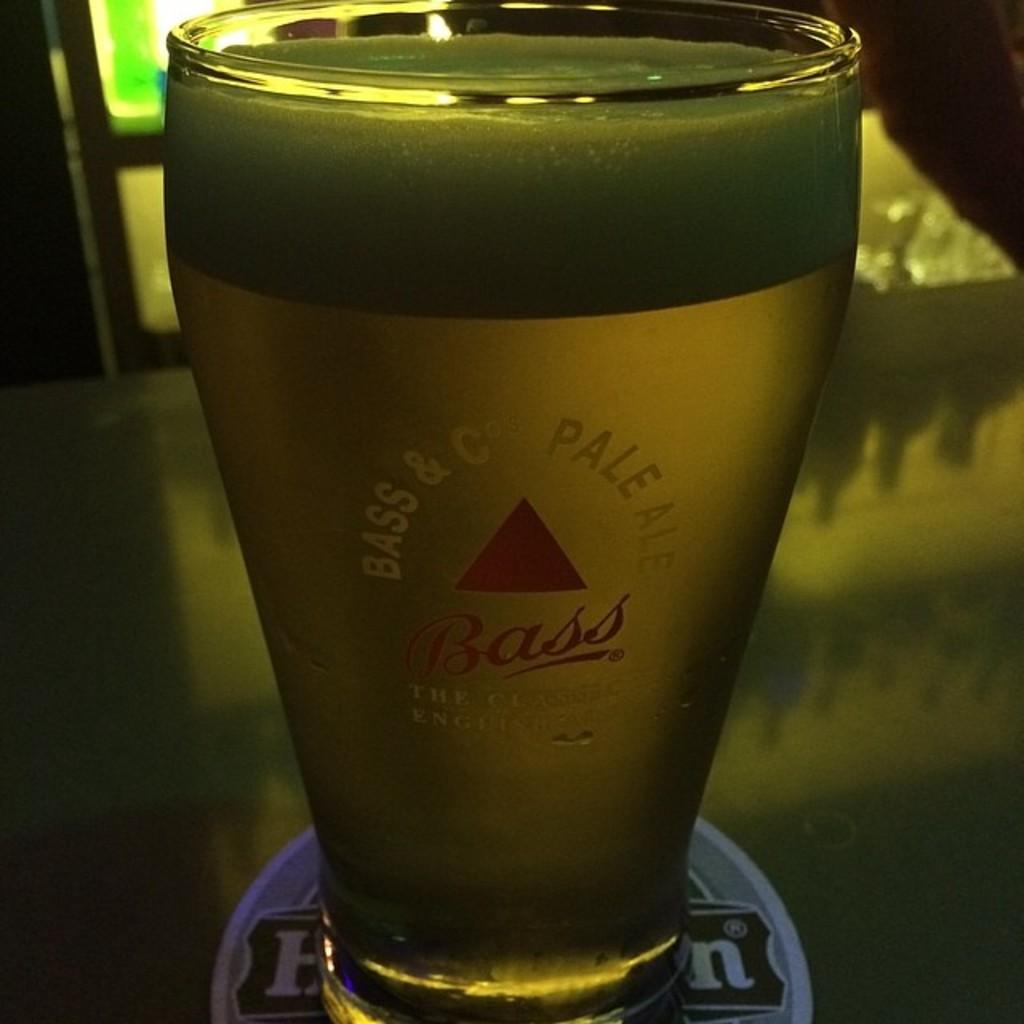<image>
Describe the image concisely. A glass of Bass pale ale sits on a round coaster on a bar. 